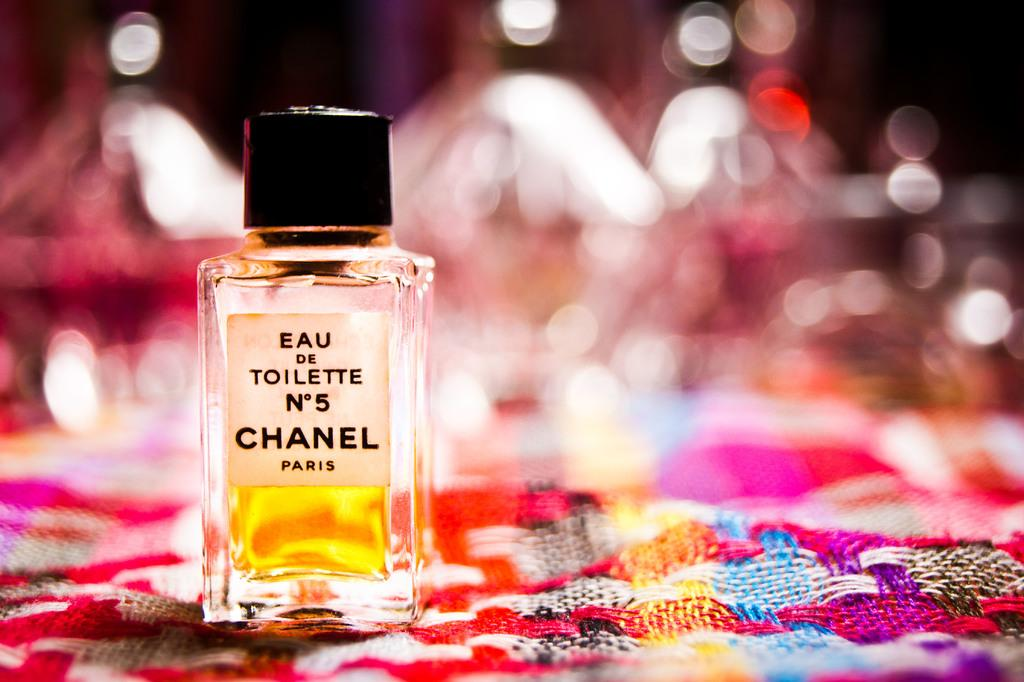<image>
Present a compact description of the photo's key features. a small bottle on top of a blanket that says 'eau de toilette n5 chanel' onit 